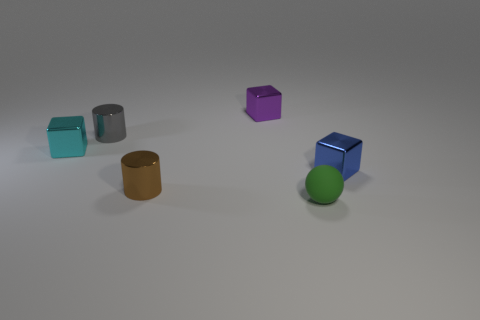Add 3 cyan metal blocks. How many objects exist? 9 Subtract all cylinders. How many objects are left? 4 Subtract 0 gray blocks. How many objects are left? 6 Subtract all brown spheres. Subtract all tiny rubber spheres. How many objects are left? 5 Add 3 small cyan metal blocks. How many small cyan metal blocks are left? 4 Add 1 large gray rubber cubes. How many large gray rubber cubes exist? 1 